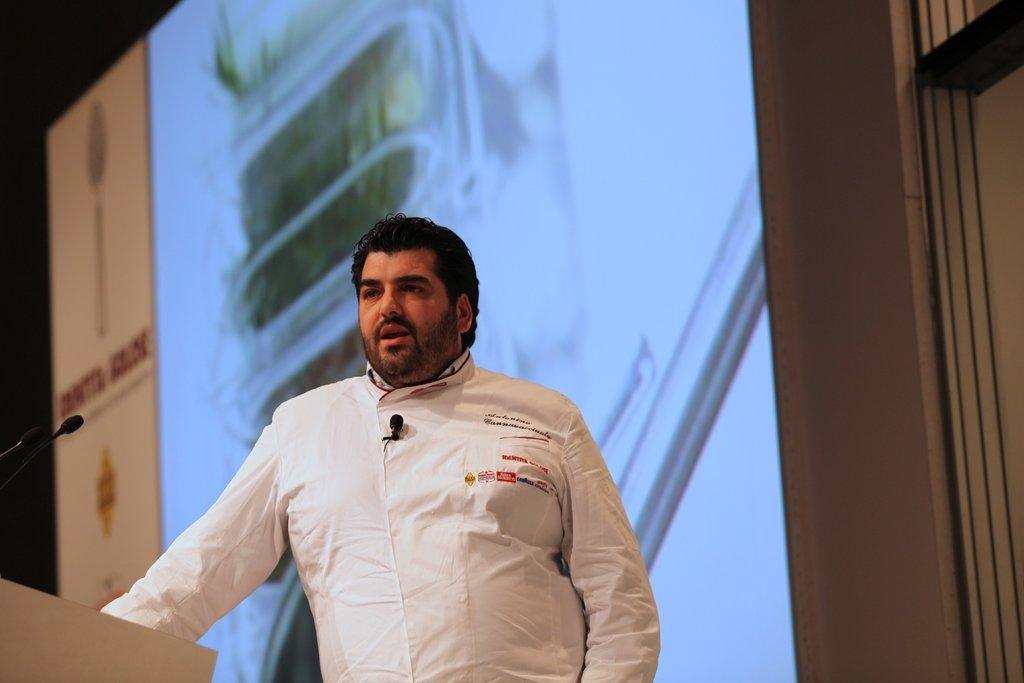What is the man in the image doing? The man is standing at the podium in the image. What objects are present that might be used for amplifying sound? There are microphones in the image. What can be seen in the background of the image? There is a screen visible in the background of the image. What type of angle is the tank being viewed from in the image? There is no tank present in the image, so it is not possible to determine the angle from which it might be viewed. 